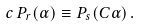<formula> <loc_0><loc_0><loc_500><loc_500>c \, P _ { r } ( \alpha ) \equiv P _ { s } ( C \alpha ) \, .</formula> 